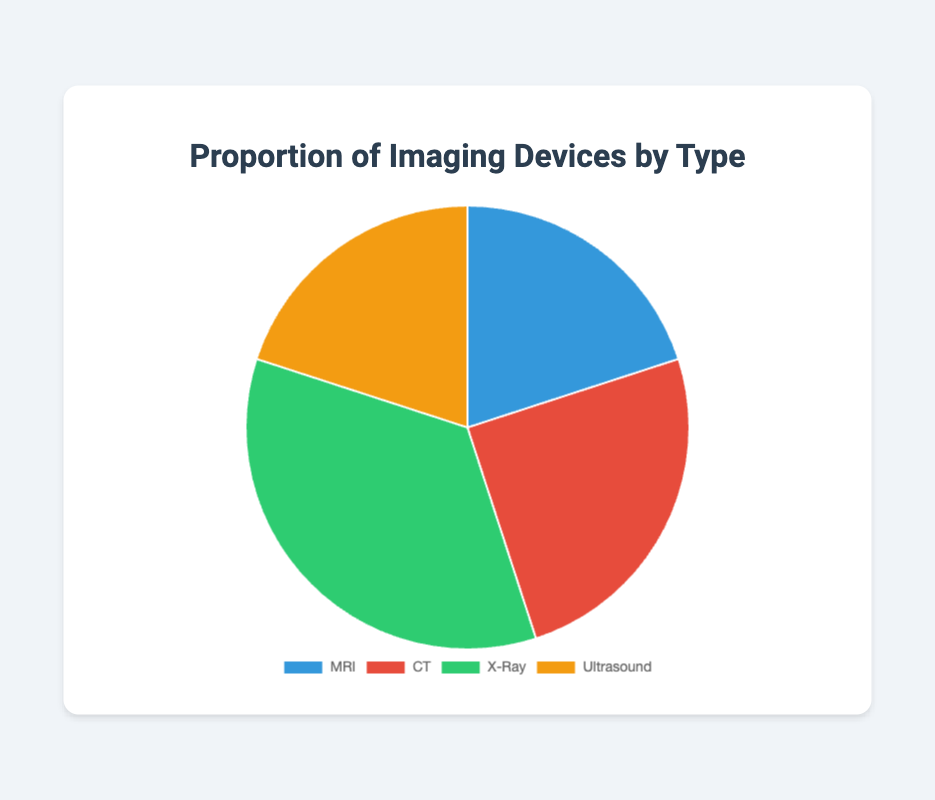Which imaging device type has the highest proportion? The X-Ray category has the largest slice in the pie chart, indicating the highest proportion.
Answer: X-Ray Which imaging device types have equal proportions? By visually inspecting the pie chart, MRI and Ultrasound have equal-sized slices, indicating they both hold the same proportion.
Answer: MRI and Ultrasound What is the combined proportion of MRI and CT devices? By adding the proportions of MRI (20%) and CT (25%), the combined proportion is 20 + 25 = 45%.
Answer: 45% Is the proportion of Ultrasound devices greater than CT devices? By comparing the proportions, Ultrasound has 20% and CT has 25%, so the proportion of Ultrasound is not greater than CT.
Answer: No What is the difference in proportion between X-Ray and MRI devices? X-Ray has 35% and MRI has 20%. Subtracting MRI's proportion from X-Ray's gives 35 - 20 = 15%.
Answer: 15% If the total number of devices is 1000, how many are CT devices? The proportion for CT is 25%. Multiplying this by the total number of devices gives 0.25 * 1000 = 250 devices.
Answer: 250 Rank the imaging device types from highest to lowest proportion. By comparing the proportions visually, the order from highest to lowest is X-Ray (35%), CT (25%), and MRI and Ultrasound (both 20%).
Answer: X-Ray, CT, MRI, Ultrasound Which device type has a proportion closest to 20% but not equal to it? By visually inspecting the chart and comparing proportions, CT has a proportion of 25%, which is closest to 20% but not equal to it.
Answer: CT How much larger is the proportion of X-Ray devices compared to Ultrasound? X-Ray has 35% while Ultrasound has 20%. The difference is 35 - 20 = 15%.
Answer: 15% 